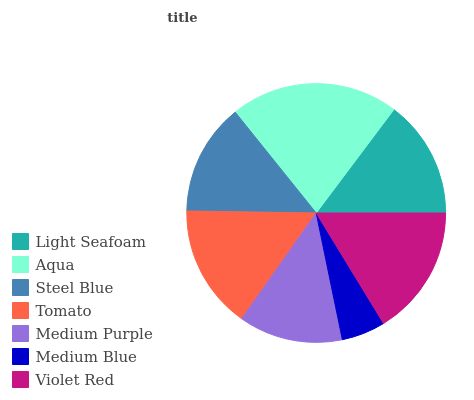Is Medium Blue the minimum?
Answer yes or no. Yes. Is Aqua the maximum?
Answer yes or no. Yes. Is Steel Blue the minimum?
Answer yes or no. No. Is Steel Blue the maximum?
Answer yes or no. No. Is Aqua greater than Steel Blue?
Answer yes or no. Yes. Is Steel Blue less than Aqua?
Answer yes or no. Yes. Is Steel Blue greater than Aqua?
Answer yes or no. No. Is Aqua less than Steel Blue?
Answer yes or no. No. Is Light Seafoam the high median?
Answer yes or no. Yes. Is Light Seafoam the low median?
Answer yes or no. Yes. Is Violet Red the high median?
Answer yes or no. No. Is Steel Blue the low median?
Answer yes or no. No. 